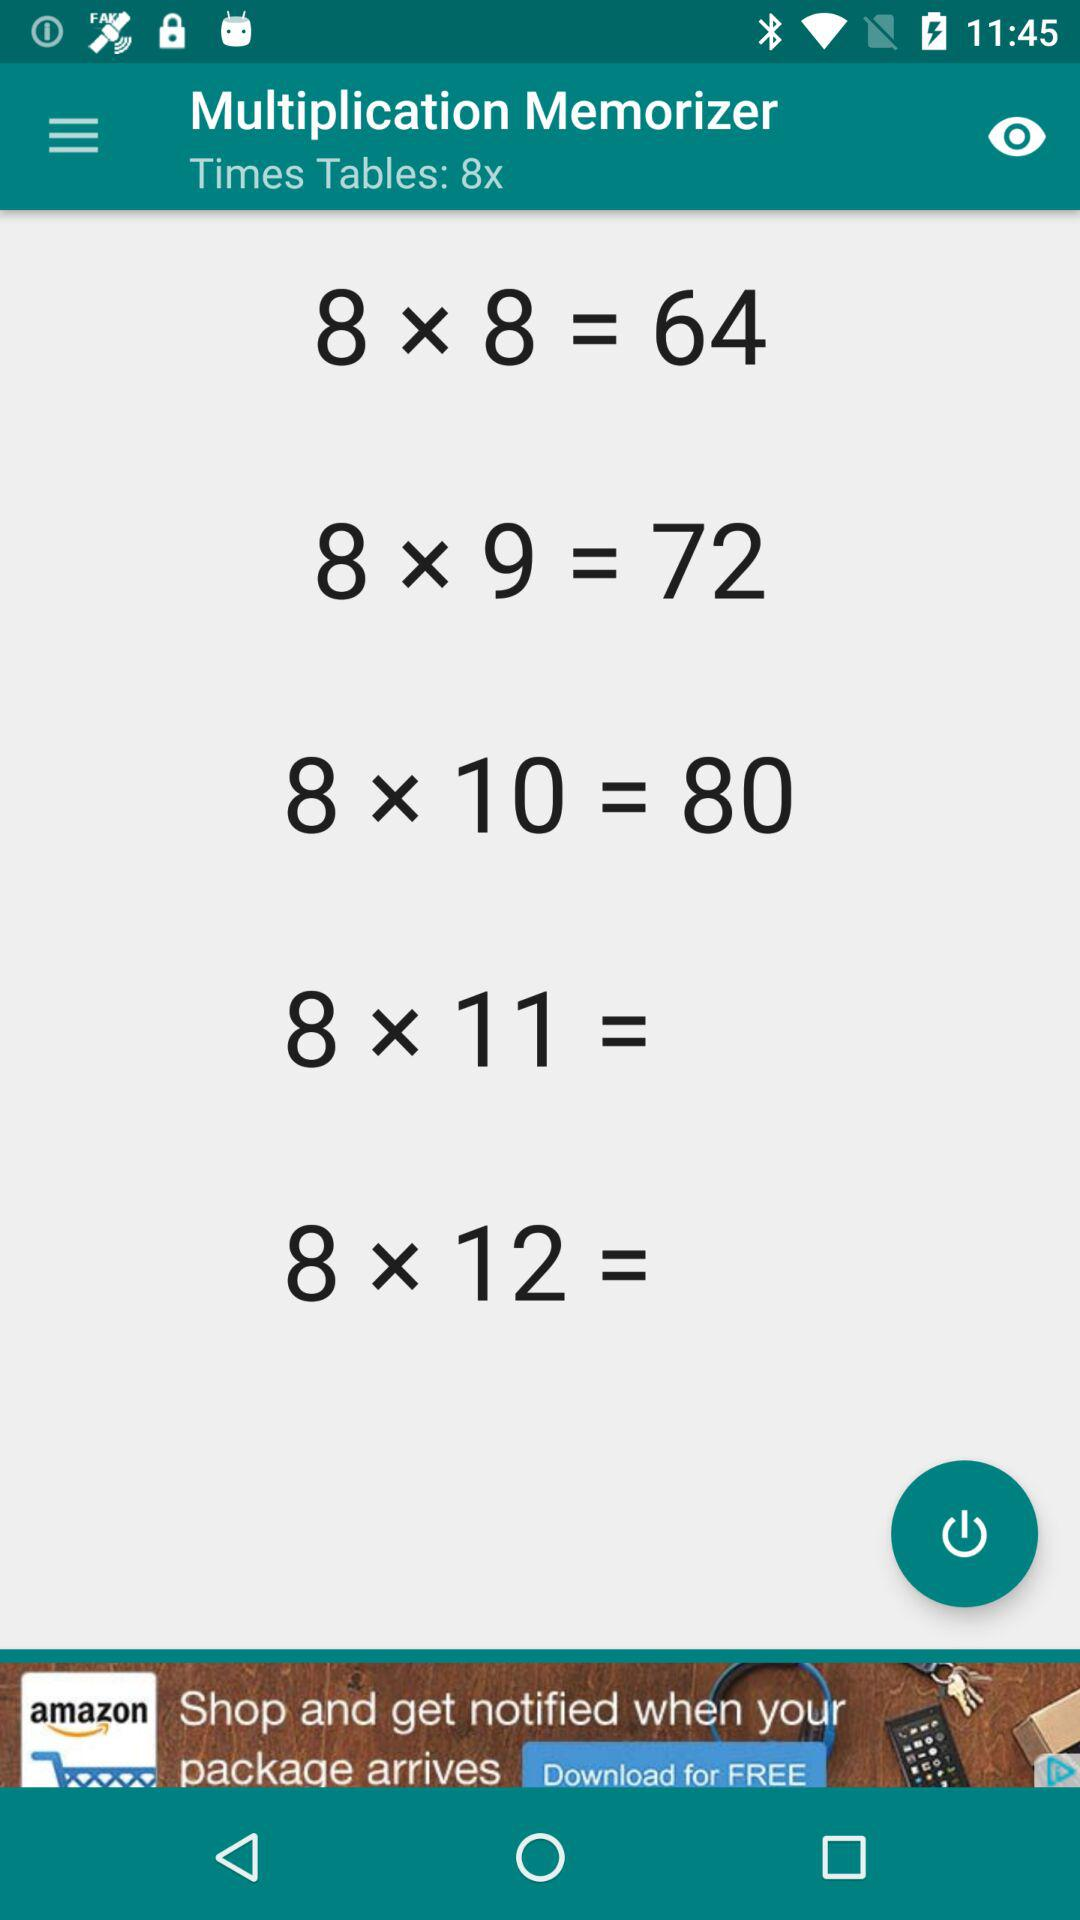What are the "Times Tables"? The "Times Tables" are 8x. 